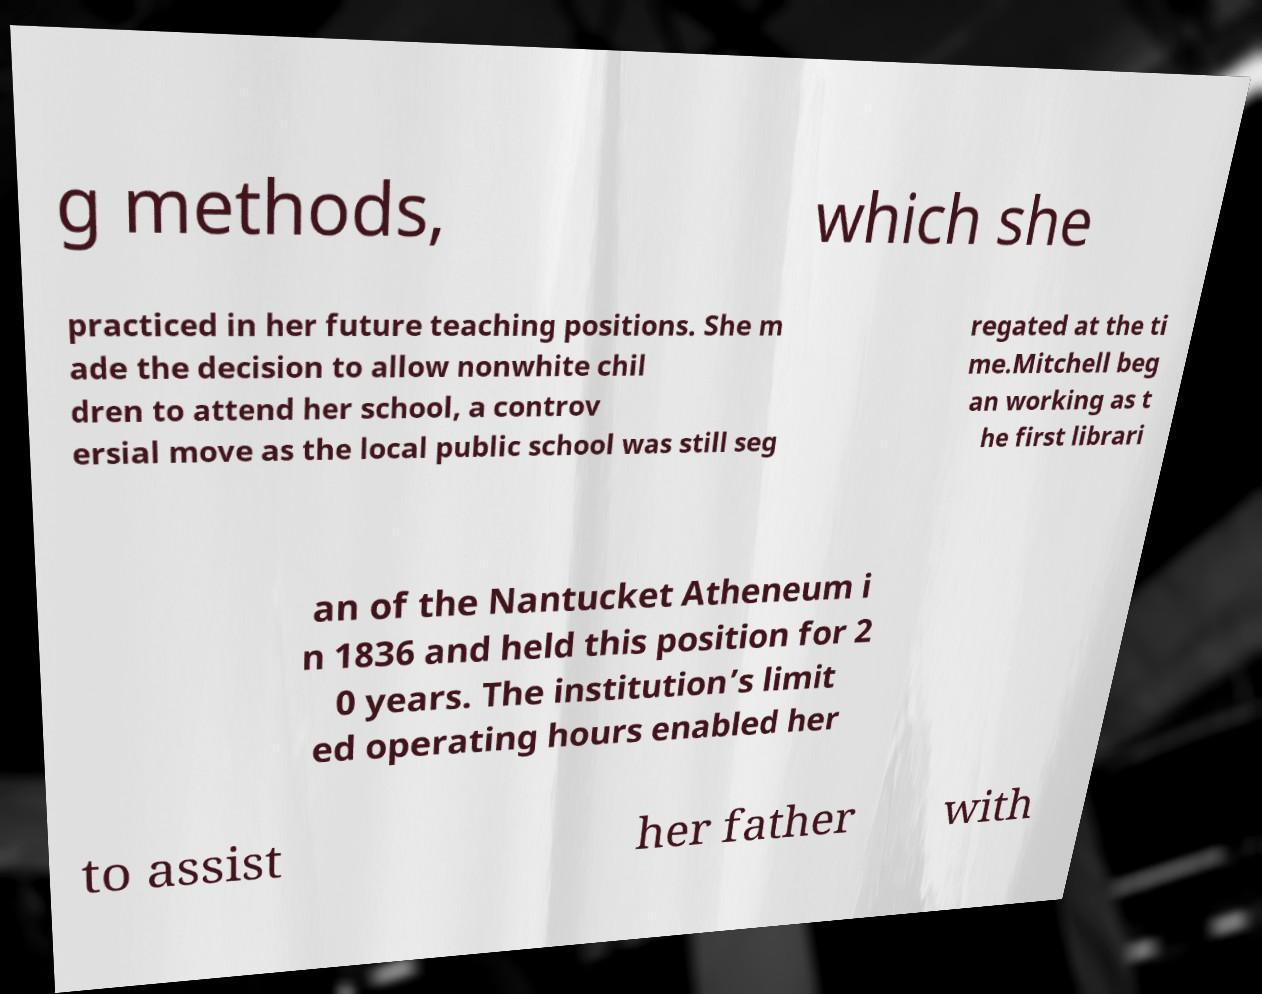Can you accurately transcribe the text from the provided image for me? g methods, which she practiced in her future teaching positions. She m ade the decision to allow nonwhite chil dren to attend her school, a controv ersial move as the local public school was still seg regated at the ti me.Mitchell beg an working as t he first librari an of the Nantucket Atheneum i n 1836 and held this position for 2 0 years. The institution’s limit ed operating hours enabled her to assist her father with 